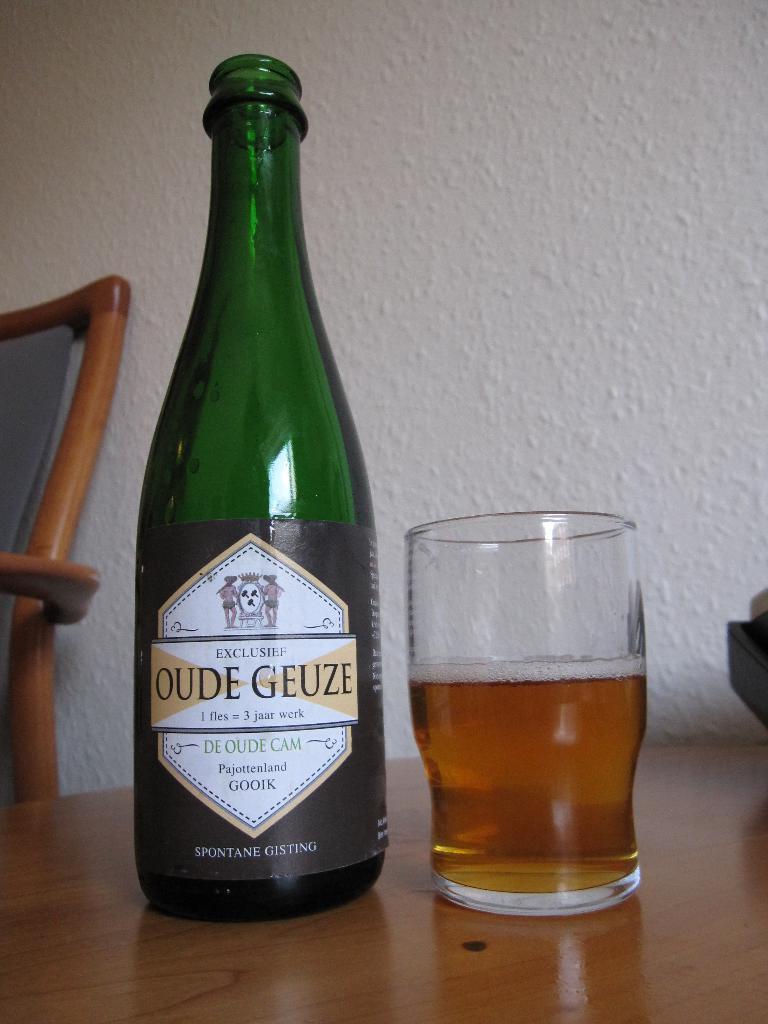Brand name of this beer?
Offer a terse response. Oude geuze. One fles equals what?
Make the answer very short. 3 jaar werk. 